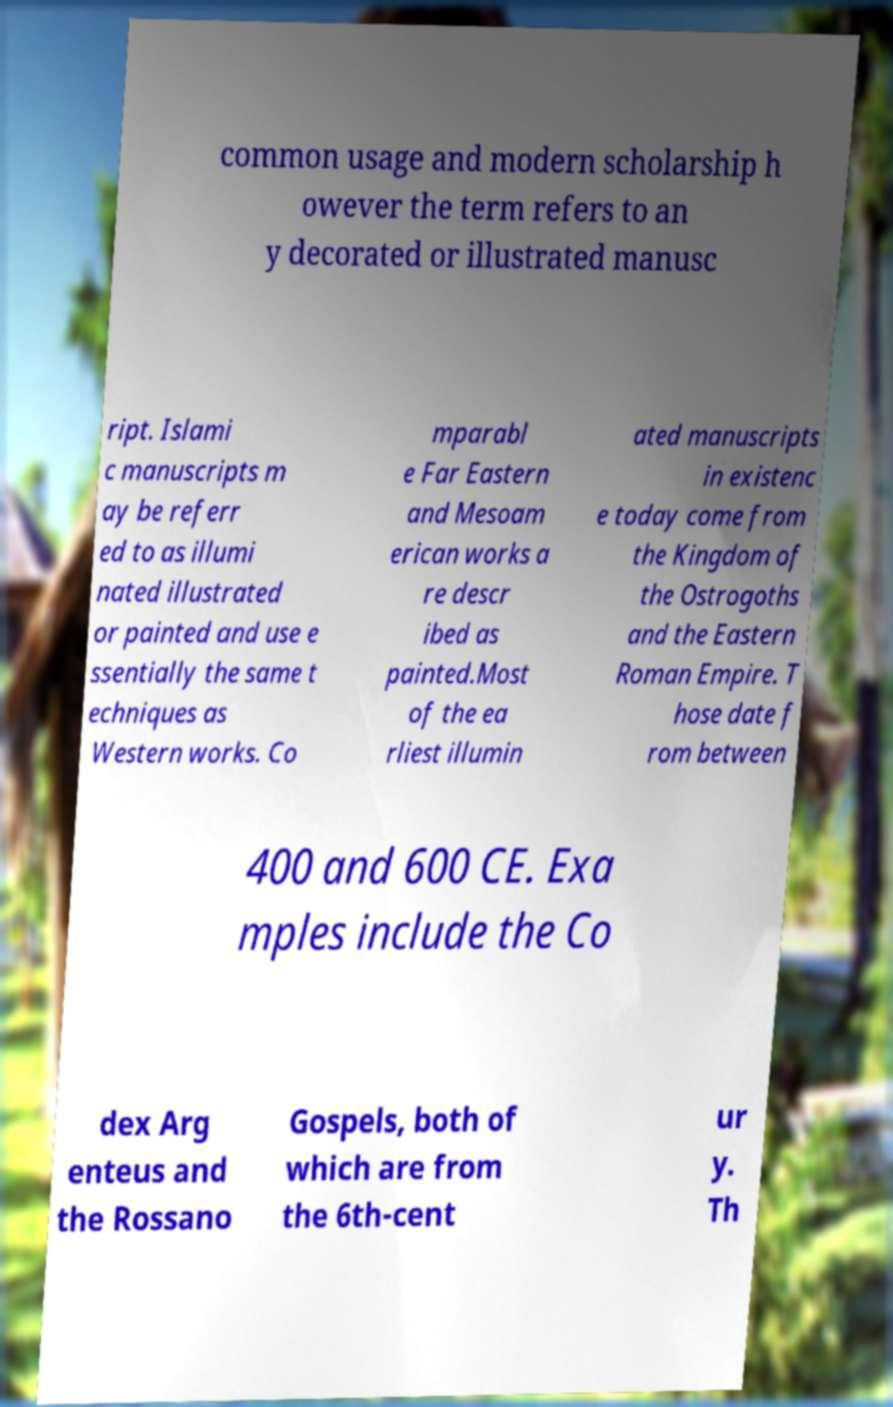What messages or text are displayed in this image? I need them in a readable, typed format. common usage and modern scholarship h owever the term refers to an y decorated or illustrated manusc ript. Islami c manuscripts m ay be referr ed to as illumi nated illustrated or painted and use e ssentially the same t echniques as Western works. Co mparabl e Far Eastern and Mesoam erican works a re descr ibed as painted.Most of the ea rliest illumin ated manuscripts in existenc e today come from the Kingdom of the Ostrogoths and the Eastern Roman Empire. T hose date f rom between 400 and 600 CE. Exa mples include the Co dex Arg enteus and the Rossano Gospels, both of which are from the 6th-cent ur y. Th 